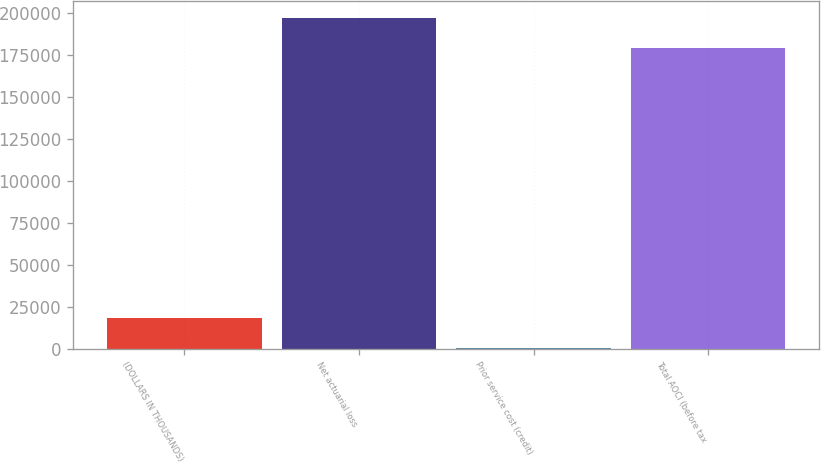<chart> <loc_0><loc_0><loc_500><loc_500><bar_chart><fcel>(DOLLARS IN THOUSANDS)<fcel>Net actuarial loss<fcel>Prior service cost (credit)<fcel>Total AOCI (before tax<nl><fcel>18227.5<fcel>197126<fcel>307<fcel>179205<nl></chart> 